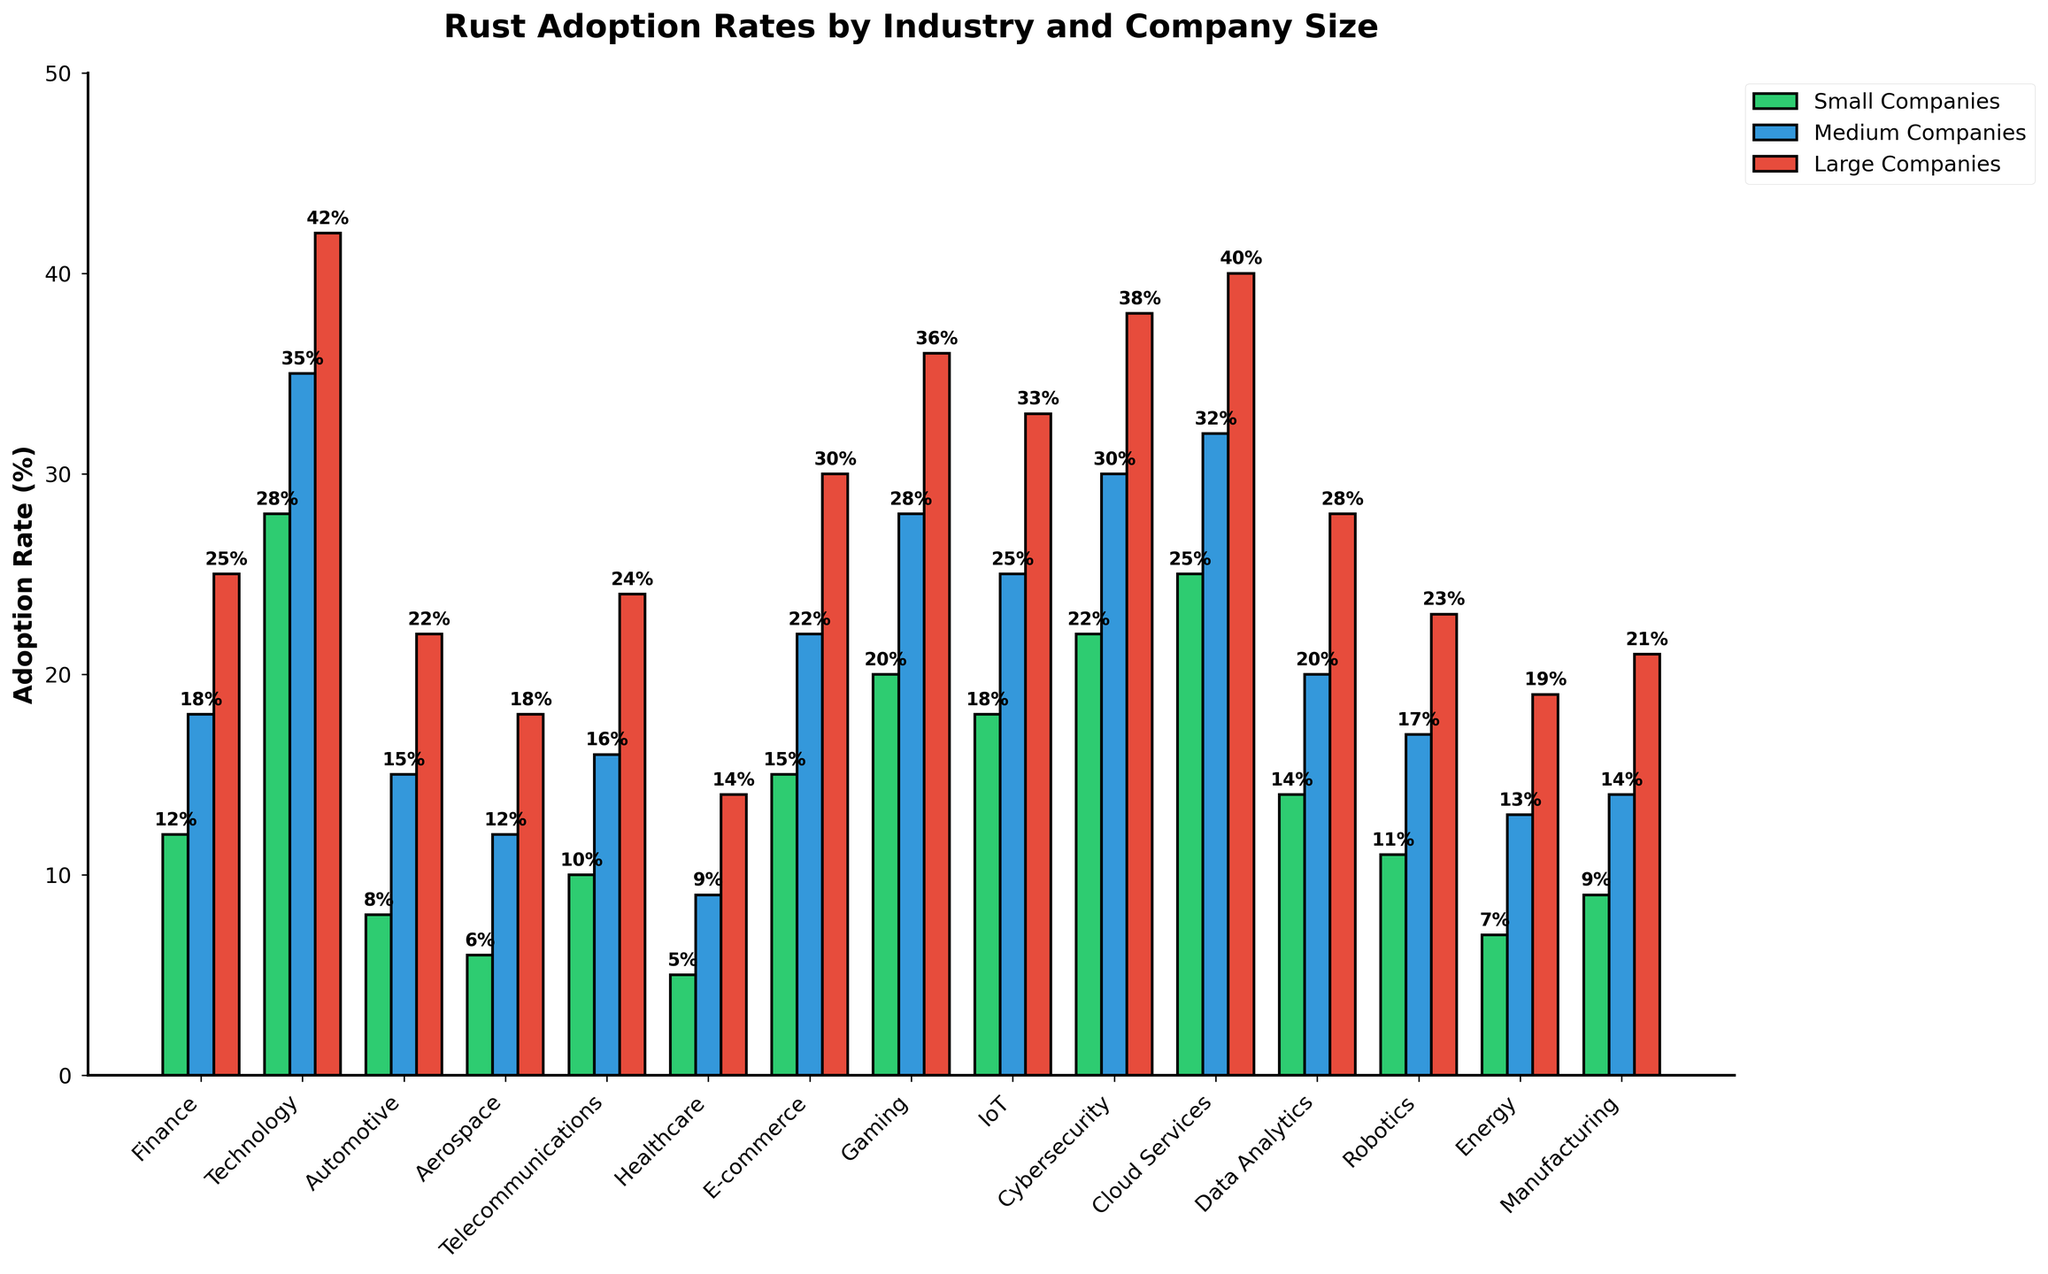What's the highest Rust adoption rate in the Technology industry? Look at the bars representing the Technology industry, identify which company's percentage is the highest. Here, the Tech industry shows 42% adoption for large companies.
Answer: 42% In the Finance industry, which company size has the lowest adoption rate share? Look at the bars representing the Finance industry, identify which company's percentage is the lowest. Small companies have the lowest adoption rate at 12%.
Answer: Small companies Does the E-commerce industry have a higher Rust adoption rate in small or large companies? Compare the heights of the bars for the small and large companies in the E-commerce industry. The large companies have a higher adoption rate of 30% compared to 15% for small companies.
Answer: Large companies Calculate the average adoption rate of Rust in medium-sized companies across all industries. Add all adoption rates for medium companies and divide by the number of industries: (18 + 35 + 15 + 12 + 16 + 9 + 22 + 28 + 25 + 30 + 32 + 20 + 17 + 13 + 14) / 15 = 23%.
Answer: 23% Which sector has the largest gap in Rust adoption rates between small and large companies? Calculate the difference between the adoption rates for small and large companies in each industry and find the maximum. Technology has the largest gap of 42% - 28% = 14%.
Answer: Technology What is the sum of Rust adoption rates for all small companies in the industries? Add all adoption rates for small companies across each industry: 12 + 28 + 8 + 6 + 10 + 5 + 15 + 20 + 18 + 22 + 25 + 14 + 11 + 7 + 9 = 210.
Answer: 210 In the Gaming industry, how much lower is the adoption rate for medium companies than for large companies? Subtract the adoption rate of medium companies from that of large companies in the Gaming industry: 36% - 28% = 8%.
Answer: 8% Does the Cybersecurity industry have a higher adoption rate in large companies than the Healthcare industry? Compare the bars representing the large companies' adoption rates in the Cybersecurity and Healthcare industries. Cybersecurity has a higher rate (38%) than Healthcare (14%).
Answer: Yes Among small companies, which industry has the third highest Rust adoption rate? Rank the industries by the Rust adoption rates for small companies and find the third highest. Cloud Services has the highest (25%), Technology the second highest (28%), and IoT the third highest (18%).
Answer: IoT What is the difference in adoption rates between small and medium companies for the Data Analytics industry? Subtract the adoption rate of small companies from that of medium companies in the Data Analytics industry: 20% - 14% = 6%.
Answer: 6% 